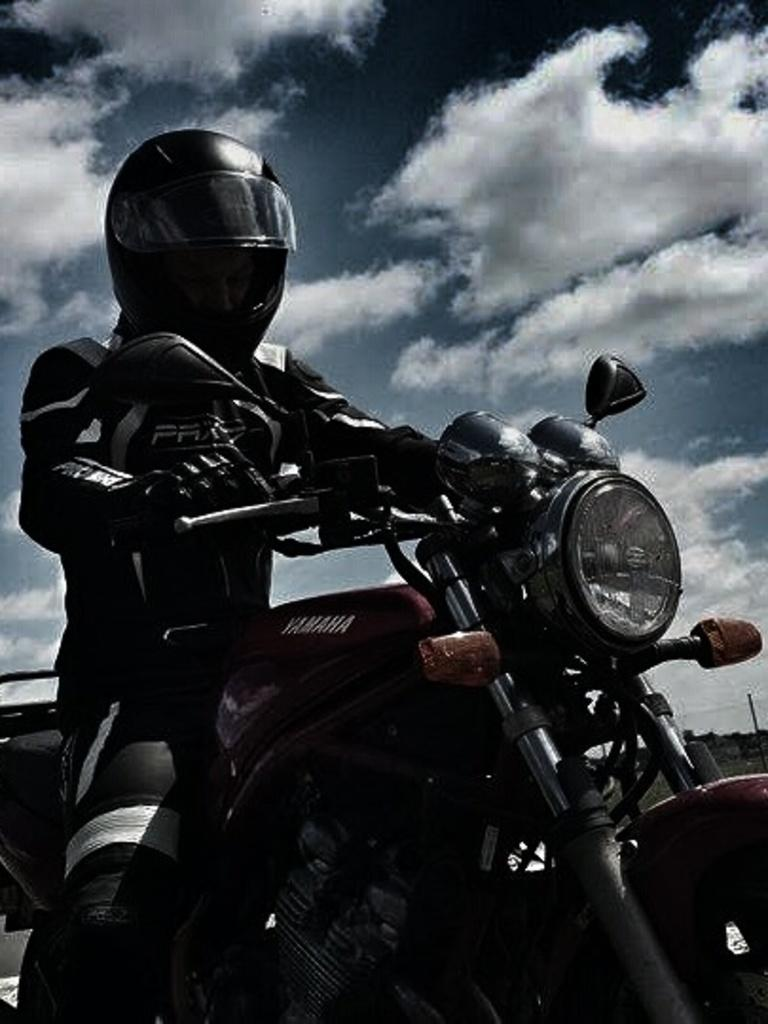What can be seen in the background of the image? The sky is visible in the background of the image. What is present in the sky? There are clouds in the sky. What is the man in the image doing? The man is riding a bike in the image. What safety precaution is the man taking while riding the bike? The man is wearing a helmet. What type of stick is the man using to ride the bike in the image? There is no stick present in the image; the man is riding a bike using pedals and handlebars. What country is the image taken in? The provided facts do not specify the country in which the image was taken. 